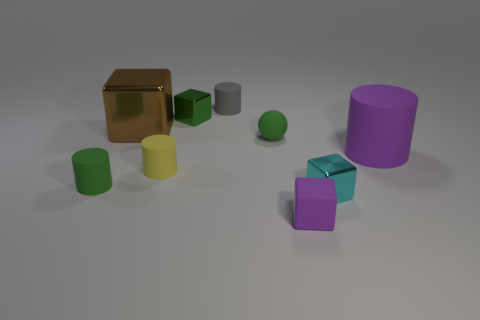Can you describe the lighting and shadows in the image? The lighting in the image is soft and diffuse, casting gentle shadows to the right of the objects. This subtle shadowing suggests an ambient light source, giving the scene a calm and even light distribution.  Does the intensity of the shadows give any clues about the light source? Yes, the softness and the low contrast of the shadows indicate a light source that is either distant or diffused through an opaque medium, creating a uniform and indirect illumination in the image. 